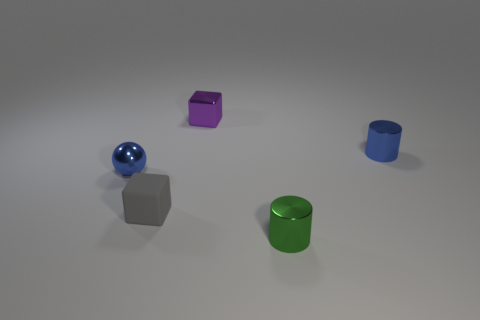There is a small ball; is it the same color as the metallic cylinder that is behind the small gray cube?
Give a very brief answer. Yes. Does the tiny metallic object to the right of the green cylinder have the same color as the tiny ball?
Provide a succinct answer. Yes. Are there any metal cylinders of the same color as the shiny ball?
Keep it short and to the point. Yes. There is a tiny cube that is in front of the tiny blue thing to the right of the purple block; what is its material?
Your answer should be compact. Rubber. What is the material of the other thing that is the same shape as the small purple thing?
Give a very brief answer. Rubber. How many other objects are there of the same material as the gray thing?
Give a very brief answer. 0. There is a metal thing on the right side of the shiny object in front of the tiny blue thing left of the small green cylinder; what is its color?
Offer a terse response. Blue. What is the material of the ball that is the same size as the green cylinder?
Give a very brief answer. Metal. What number of objects are blue things that are to the right of the metallic cube or large brown cylinders?
Provide a short and direct response. 1. Is there a tiny gray rubber object?
Provide a succinct answer. Yes. 